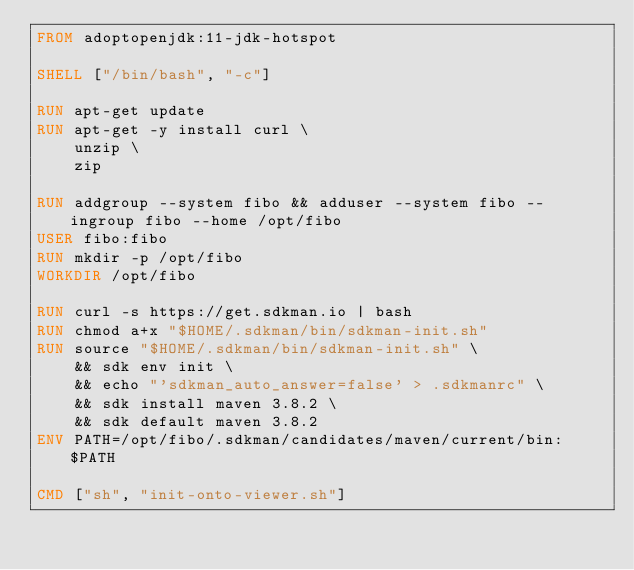Convert code to text. <code><loc_0><loc_0><loc_500><loc_500><_Dockerfile_>FROM adoptopenjdk:11-jdk-hotspot

SHELL ["/bin/bash", "-c"]

RUN apt-get update
RUN apt-get -y install curl \
    unzip \
    zip

RUN addgroup --system fibo && adduser --system fibo --ingroup fibo --home /opt/fibo
USER fibo:fibo
RUN mkdir -p /opt/fibo
WORKDIR /opt/fibo

RUN curl -s https://get.sdkman.io | bash
RUN chmod a+x "$HOME/.sdkman/bin/sdkman-init.sh"
RUN source "$HOME/.sdkman/bin/sdkman-init.sh" \
    && sdk env init \
    && echo "'sdkman_auto_answer=false' > .sdkmanrc" \
    && sdk install maven 3.8.2 \
    && sdk default maven 3.8.2
ENV PATH=/opt/fibo/.sdkman/candidates/maven/current/bin:$PATH

CMD ["sh", "init-onto-viewer.sh"]</code> 